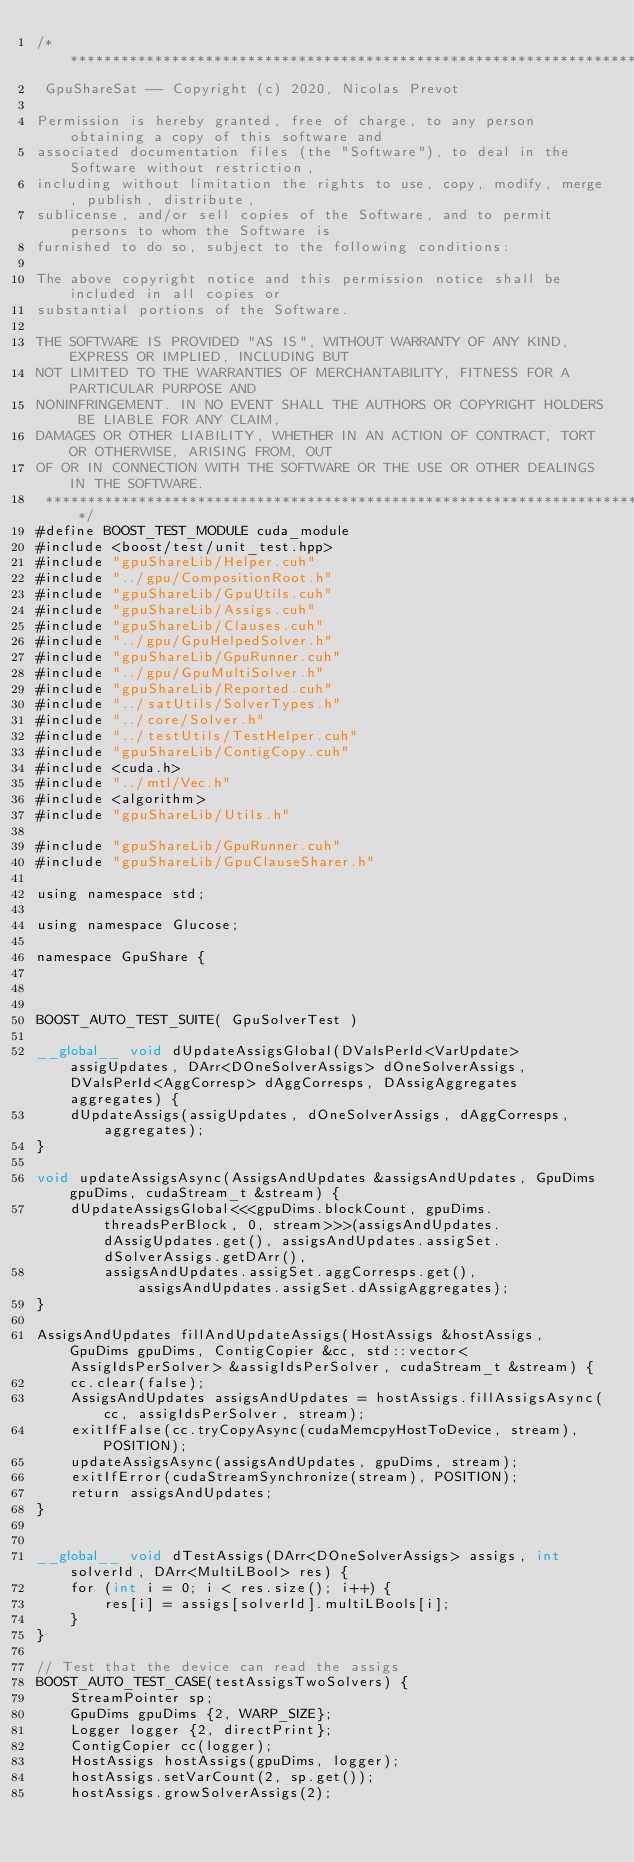Convert code to text. <code><loc_0><loc_0><loc_500><loc_500><_Cuda_>/***************************************************************************************
 GpuShareSat -- Copyright (c) 2020, Nicolas Prevot

Permission is hereby granted, free of charge, to any person obtaining a copy of this software and
associated documentation files (the "Software"), to deal in the Software without restriction,
including without limitation the rights to use, copy, modify, merge, publish, distribute,
sublicense, and/or sell copies of the Software, and to permit persons to whom the Software is
furnished to do so, subject to the following conditions:

The above copyright notice and this permission notice shall be included in all copies or
substantial portions of the Software.

THE SOFTWARE IS PROVIDED "AS IS", WITHOUT WARRANTY OF ANY KIND, EXPRESS OR IMPLIED, INCLUDING BUT
NOT LIMITED TO THE WARRANTIES OF MERCHANTABILITY, FITNESS FOR A PARTICULAR PURPOSE AND
NONINFRINGEMENT. IN NO EVENT SHALL THE AUTHORS OR COPYRIGHT HOLDERS BE LIABLE FOR ANY CLAIM,
DAMAGES OR OTHER LIABILITY, WHETHER IN AN ACTION OF CONTRACT, TORT OR OTHERWISE, ARISING FROM, OUT
OF OR IN CONNECTION WITH THE SOFTWARE OR THE USE OR OTHER DEALINGS IN THE SOFTWARE.
 **************************************************************************************************/
#define BOOST_TEST_MODULE cuda_module
#include <boost/test/unit_test.hpp>
#include "gpuShareLib/Helper.cuh"
#include "../gpu/CompositionRoot.h"
#include "gpuShareLib/GpuUtils.cuh"
#include "gpuShareLib/Assigs.cuh"
#include "gpuShareLib/Clauses.cuh"
#include "../gpu/GpuHelpedSolver.h"
#include "gpuShareLib/GpuRunner.cuh"
#include "../gpu/GpuMultiSolver.h"
#include "gpuShareLib/Reported.cuh"
#include "../satUtils/SolverTypes.h"
#include "../core/Solver.h"
#include "../testUtils/TestHelper.cuh"
#include "gpuShareLib/ContigCopy.cuh"
#include <cuda.h>
#include "../mtl/Vec.h"
#include <algorithm>
#include "gpuShareLib/Utils.h"

#include "gpuShareLib/GpuRunner.cuh"
#include "gpuShareLib/GpuClauseSharer.h"

using namespace std;

using namespace Glucose;

namespace GpuShare {



BOOST_AUTO_TEST_SUITE( GpuSolverTest )

__global__ void dUpdateAssigsGlobal(DValsPerId<VarUpdate> assigUpdates, DArr<DOneSolverAssigs> dOneSolverAssigs, DValsPerId<AggCorresp> dAggCorresps, DAssigAggregates aggregates) {
    dUpdateAssigs(assigUpdates, dOneSolverAssigs, dAggCorresps, aggregates);
}

void updateAssigsAsync(AssigsAndUpdates &assigsAndUpdates, GpuDims gpuDims, cudaStream_t &stream) {
    dUpdateAssigsGlobal<<<gpuDims.blockCount, gpuDims.threadsPerBlock, 0, stream>>>(assigsAndUpdates.dAssigUpdates.get(), assigsAndUpdates.assigSet.dSolverAssigs.getDArr(),
        assigsAndUpdates.assigSet.aggCorresps.get(), assigsAndUpdates.assigSet.dAssigAggregates);
}

AssigsAndUpdates fillAndUpdateAssigs(HostAssigs &hostAssigs, GpuDims gpuDims, ContigCopier &cc, std::vector<AssigIdsPerSolver> &assigIdsPerSolver, cudaStream_t &stream) {
    cc.clear(false);
    AssigsAndUpdates assigsAndUpdates = hostAssigs.fillAssigsAsync(cc, assigIdsPerSolver, stream);
    exitIfFalse(cc.tryCopyAsync(cudaMemcpyHostToDevice, stream), POSITION);
    updateAssigsAsync(assigsAndUpdates, gpuDims, stream);
    exitIfError(cudaStreamSynchronize(stream), POSITION);
    return assigsAndUpdates;
}


__global__ void dTestAssigs(DArr<DOneSolverAssigs> assigs, int solverId, DArr<MultiLBool> res) {
    for (int i = 0; i < res.size(); i++) {
        res[i] = assigs[solverId].multiLBools[i];
    }
}

// Test that the device can read the assigs
BOOST_AUTO_TEST_CASE(testAssigsTwoSolvers) {
    StreamPointer sp;
    GpuDims gpuDims {2, WARP_SIZE};
    Logger logger {2, directPrint};
    ContigCopier cc(logger); 
    HostAssigs hostAssigs(gpuDims, logger);
    hostAssigs.setVarCount(2, sp.get());
    hostAssigs.growSolverAssigs(2);
</code> 